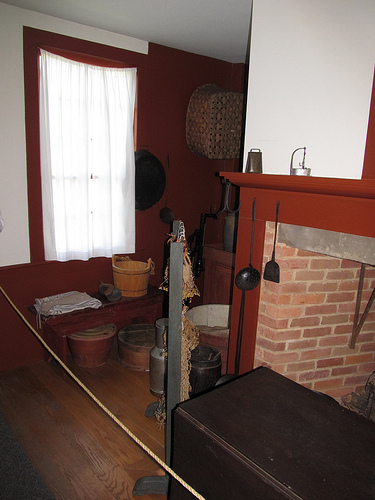How many windows are visible? There is a single window visible in the room, located on the wall adjacent to the fireplace. It is covered by a semi-transparent white curtain that allows light to filter through, giving the space a warm and inviting ambiance. 